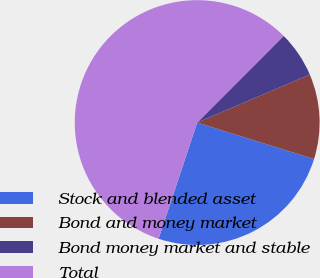Convert chart. <chart><loc_0><loc_0><loc_500><loc_500><pie_chart><fcel>Stock and blended asset<fcel>Bond and money market<fcel>Bond money market and stable<fcel>Total<nl><fcel>25.29%<fcel>11.23%<fcel>6.1%<fcel>57.39%<nl></chart> 